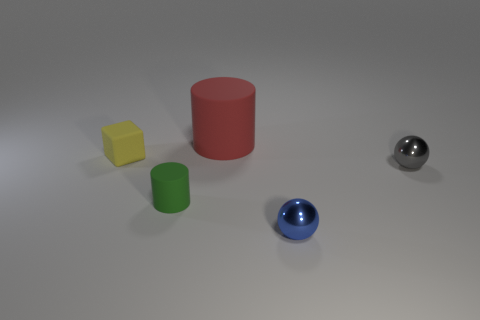Add 5 metal objects. How many objects exist? 10 Subtract all cylinders. How many objects are left? 3 Add 2 tiny matte cylinders. How many tiny matte cylinders are left? 3 Add 3 tiny cylinders. How many tiny cylinders exist? 4 Subtract 0 red cubes. How many objects are left? 5 Subtract all small green cylinders. Subtract all cylinders. How many objects are left? 2 